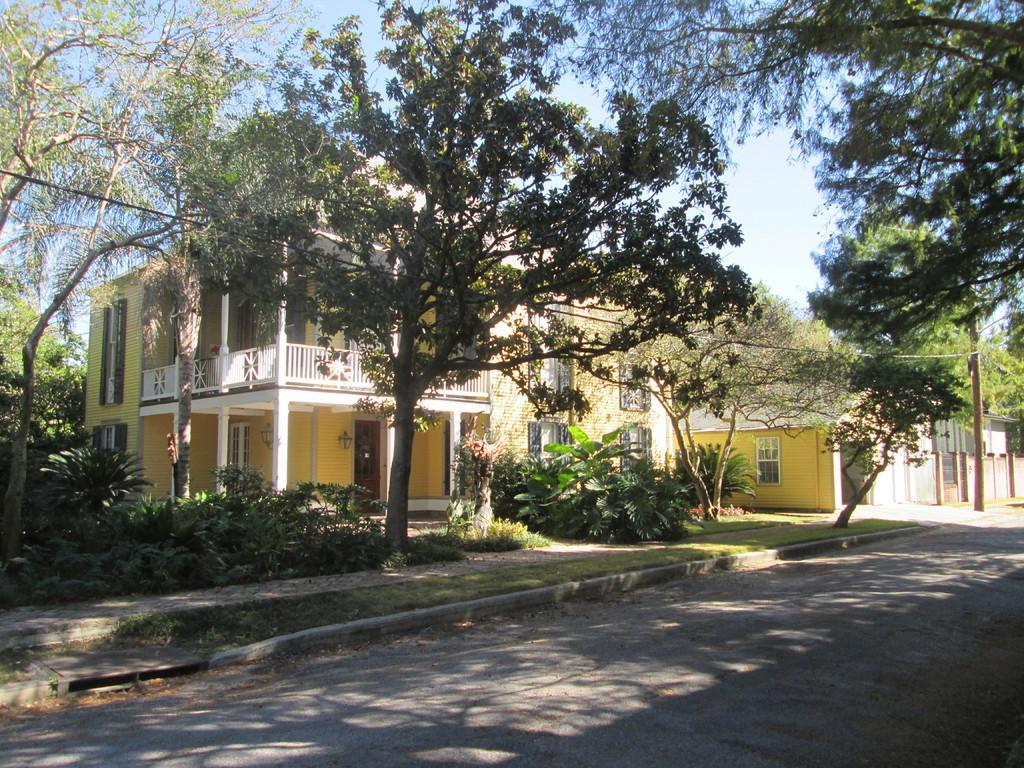Could you give a brief overview of what you see in this image? In this picture I can see buildings, plants, trees, and in the background there is the sky. 